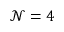<formula> <loc_0><loc_0><loc_500><loc_500>{ \mathcal { N } } = 4</formula> 